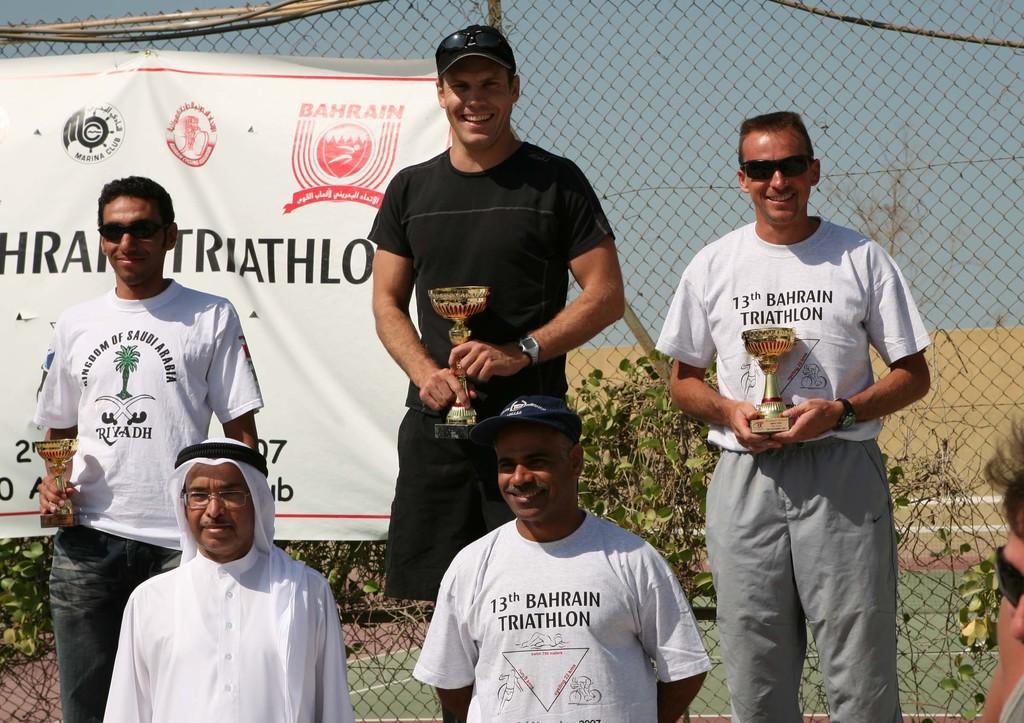How many years has the bahrain triathalon been going on?
Offer a very short reply. 13. 